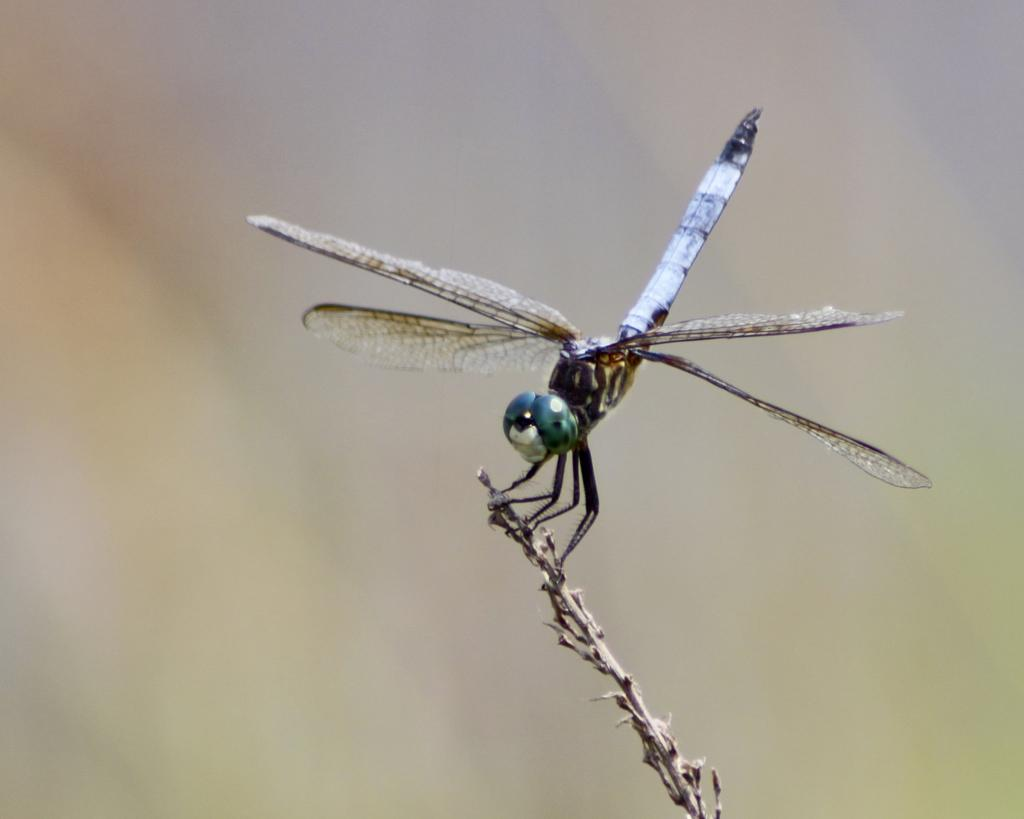What insect is present on a plant in the image? There is a dragonfly on a plant in the image. Can you describe the background of the image? The background of the image is blurry. What type of education is being offered in the image? There is no indication of education being offered in the image, as it features a dragonfly on a plant with a blurry background. 